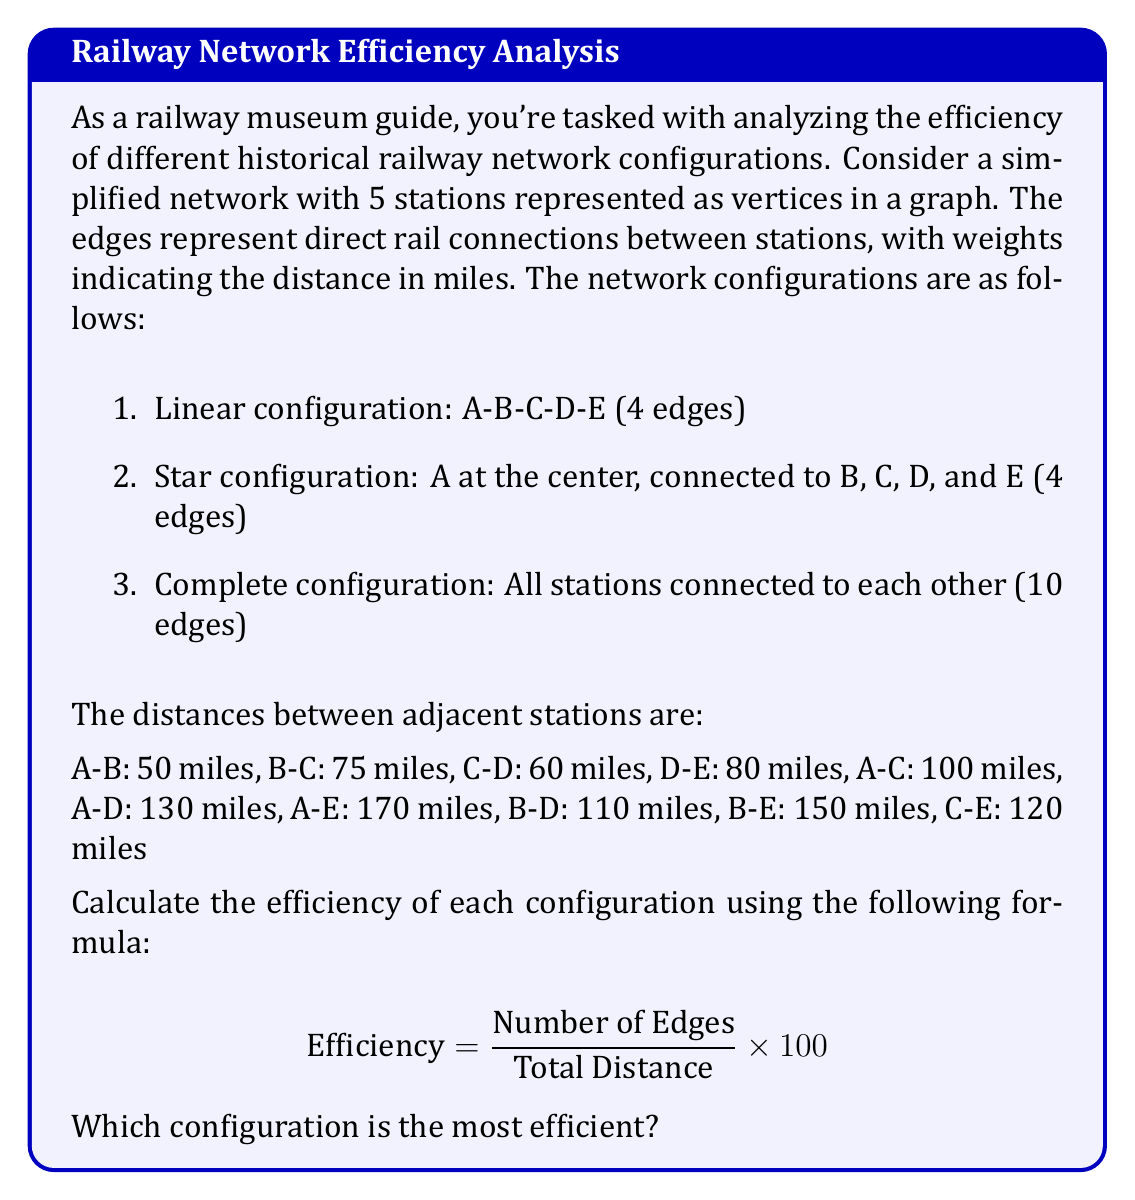What is the answer to this math problem? To solve this problem, we need to calculate the efficiency for each configuration using the given formula. Let's break it down step by step:

1. Linear configuration (A-B-C-D-E):
   Number of edges: 4
   Total distance: 50 + 75 + 60 + 80 = 265 miles
   Efficiency: $\frac{4}{265} \times 100 = 1.51\%$

2. Star configuration (A at the center):
   Number of edges: 4
   Total distance: 50 + 100 + 130 + 170 = 450 miles
   Efficiency: $\frac{4}{450} \times 100 = 0.89\%$

3. Complete configuration:
   Number of edges: 10
   Total distance: 50 + 75 + 60 + 80 + 100 + 130 + 170 + 110 + 150 + 120 = 1045 miles
   Efficiency: $\frac{10}{1045} \times 100 = 0.96\%$

To determine the most efficient configuration, we compare the efficiency percentages:

Linear configuration: 1.51%
Star configuration: 0.89%
Complete configuration: 0.96%

The linear configuration has the highest efficiency percentage, making it the most efficient among the three configurations.

This result can be interpreted in the context of historical railway development. Linear configurations were often favored in the early days of railway construction due to their simplicity and lower construction costs. They were efficient for connecting a series of towns or cities along a single route, which aligns with the higher efficiency score in this analysis.
Answer: The linear configuration (A-B-C-D-E) is the most efficient with an efficiency of 1.51%. 